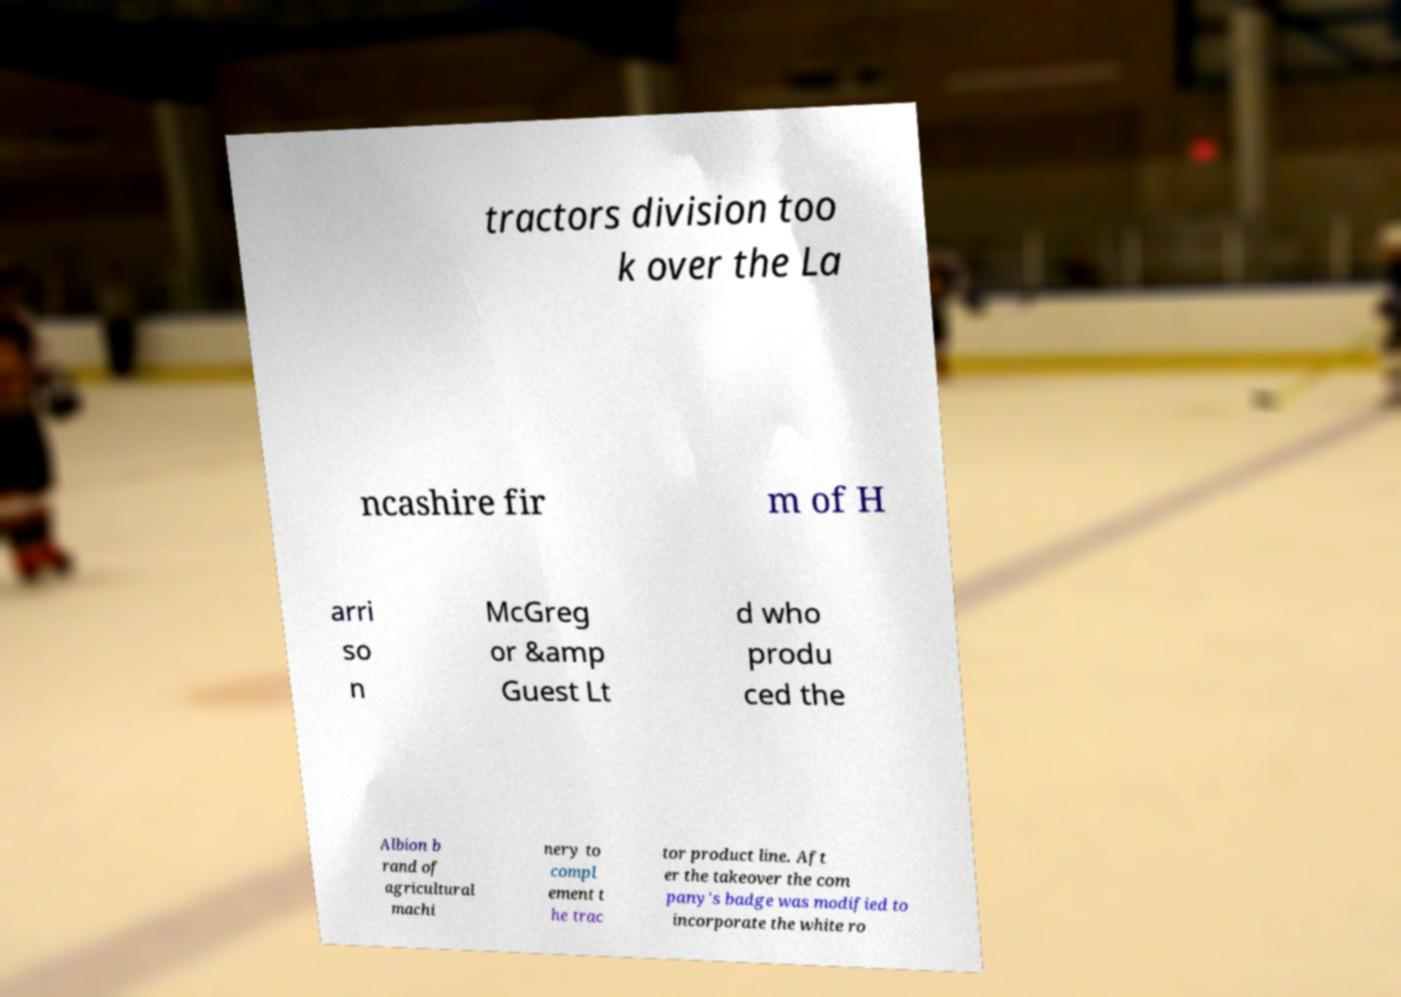Can you accurately transcribe the text from the provided image for me? tractors division too k over the La ncashire fir m of H arri so n McGreg or &amp Guest Lt d who produ ced the Albion b rand of agricultural machi nery to compl ement t he trac tor product line. Aft er the takeover the com pany's badge was modified to incorporate the white ro 